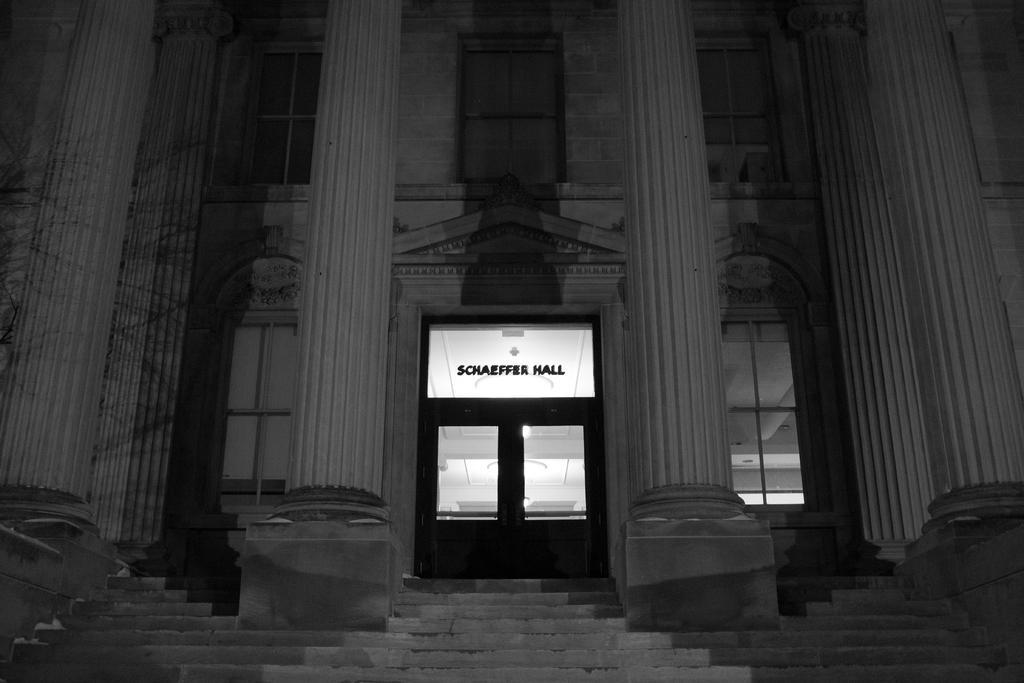In one or two sentences, can you explain what this image depicts? This is a black and white image. We can see there are pillars and there is a building with windows and a door. Inside the building there are ceiling lights. 